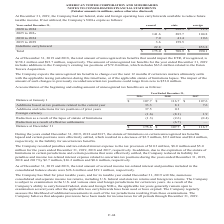From American Tower Corporation's financial document, Which years did the statute of limitations on certain unrecognized tax benefits lapse? The document contains multiple relevant values: 2019, 2018, 2017. From the document: "2019 2018 2017 At December 31, 2019, the Company had net federal, state and foreign operating loss carryforwards available to reduce fu As of December..." Also, Which years did the company record penalties and tax-related interest expense? The document contains multiple relevant values: 2019, 2018, 2017. From the document: "2019 2018 2017 2019 2018 2017 At December 31, 2019, the Company had net federal, state and foreign operating loss carryforwards available to reduce fu..." Also, What was the foreign currency in 2019? According to the financial document, (1.6) (in millions). The relevant text states: "Foreign currency (1.6) (8.1) 1.9..." Also, Which years was the balance at January 1 above $100 million? Counting the relevant items in the document: 2019, 2018, 2017, I find 3 instances. The key data points involved are: 2017, 2018, 2019. Also, Which years was the Additions based on tax positions related to the current year above $10 million? Based on the analysis, there are 1 instances. The counting process: 2019. Also, can you calculate: What was the percentage change in the balance at December 31 between 2018 and 2019? To answer this question, I need to perform calculations using the financial data. The calculation is: ($175.6-$107.7)/$107.7, which equals 63.05 (percentage). This is based on the information: "Balance at January 1 $ 107.7 $ 116.7 $ 107.6 Balance at December 31 $ 175.6 $ 107.7 $ 116.7..." The key data points involved are: 107.7, 175.6. 